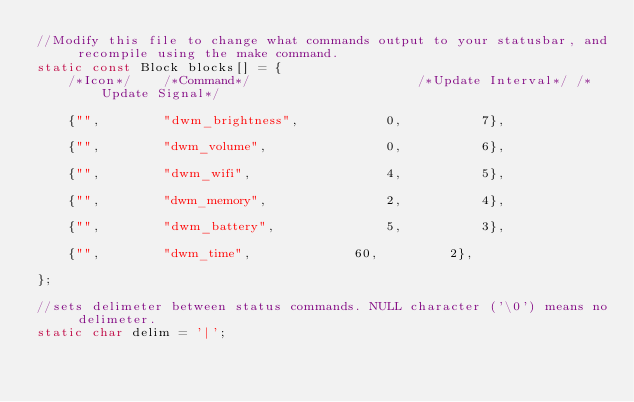<code> <loc_0><loc_0><loc_500><loc_500><_C_>//Modify this file to change what commands output to your statusbar, and recompile using the make command.
static const Block blocks[] = {
	/*Icon*/	/*Command*/		                /*Update Interval*/	/*Update Signal*/

	{"", 		"dwm_brightness",			0,			7},
                             
	{"", 		"dwm_volume",				0,			6},
                             
	{"", 		"dwm_wifi",			        4,			5},
                             
	{"", 		"dwm_memory",				2,			4},
                             
	{"", 		"dwm_battery",				5,			3},
                             
	{"", 		"dwm_time",				60,			2},

};

//sets delimeter between status commands. NULL character ('\0') means no delimeter.
static char delim = '|';
</code> 